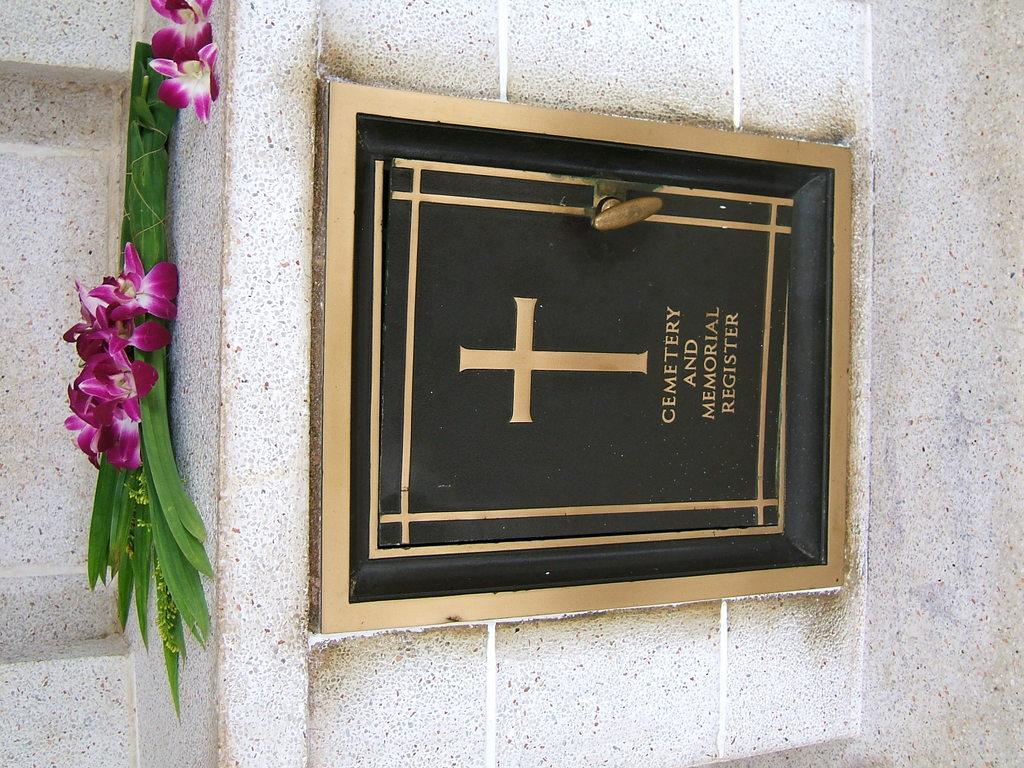<image>
Present a compact description of the photo's key features. a black and gold image of a cross in a cemetery and memorial register 